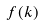<formula> <loc_0><loc_0><loc_500><loc_500>f ( k )</formula> 